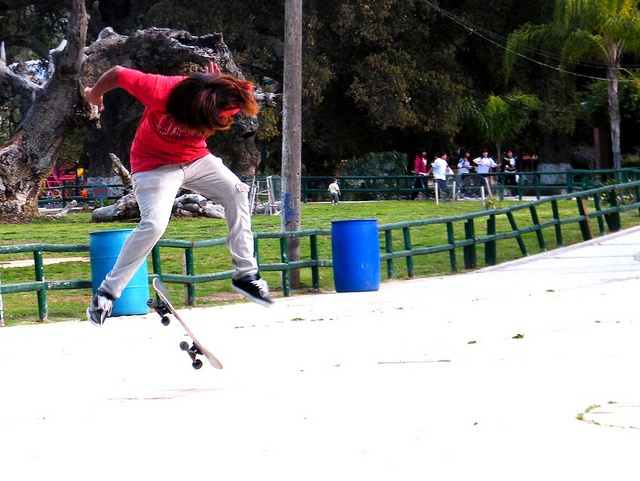Describe the objects in this image and their specific colors. I can see people in black, lavender, darkgray, and brown tones, skateboard in black, lightgray, darkgray, and gray tones, people in black, gray, navy, and maroon tones, people in black, white, navy, and gray tones, and people in black, brown, and purple tones in this image. 